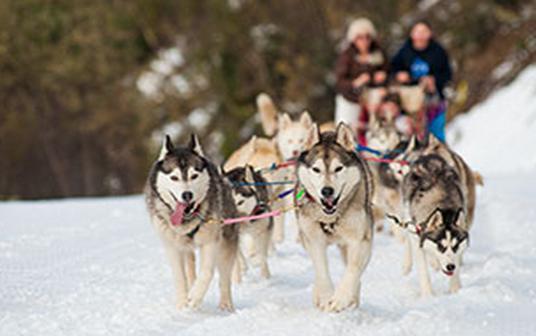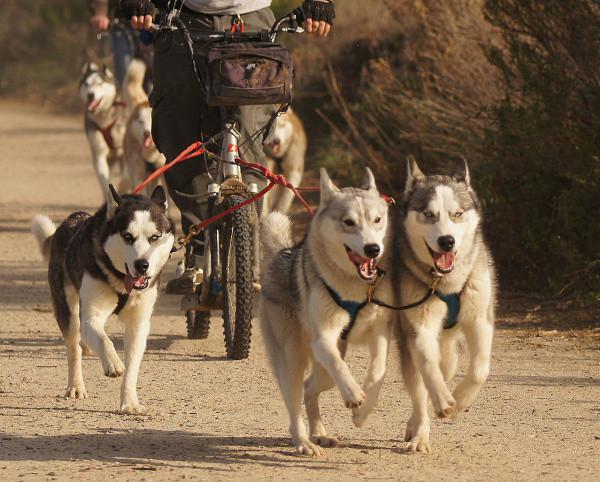The first image is the image on the left, the second image is the image on the right. Considering the images on both sides, is "The left image shows a sled dog team heading forward over snow, and the right image shows dogs hitched to a forward-facing wheeled vehicle on a path bare of snow." valid? Answer yes or no. Yes. The first image is the image on the left, the second image is the image on the right. For the images displayed, is the sentence "All of the dogs are moving forward." factually correct? Answer yes or no. Yes. 